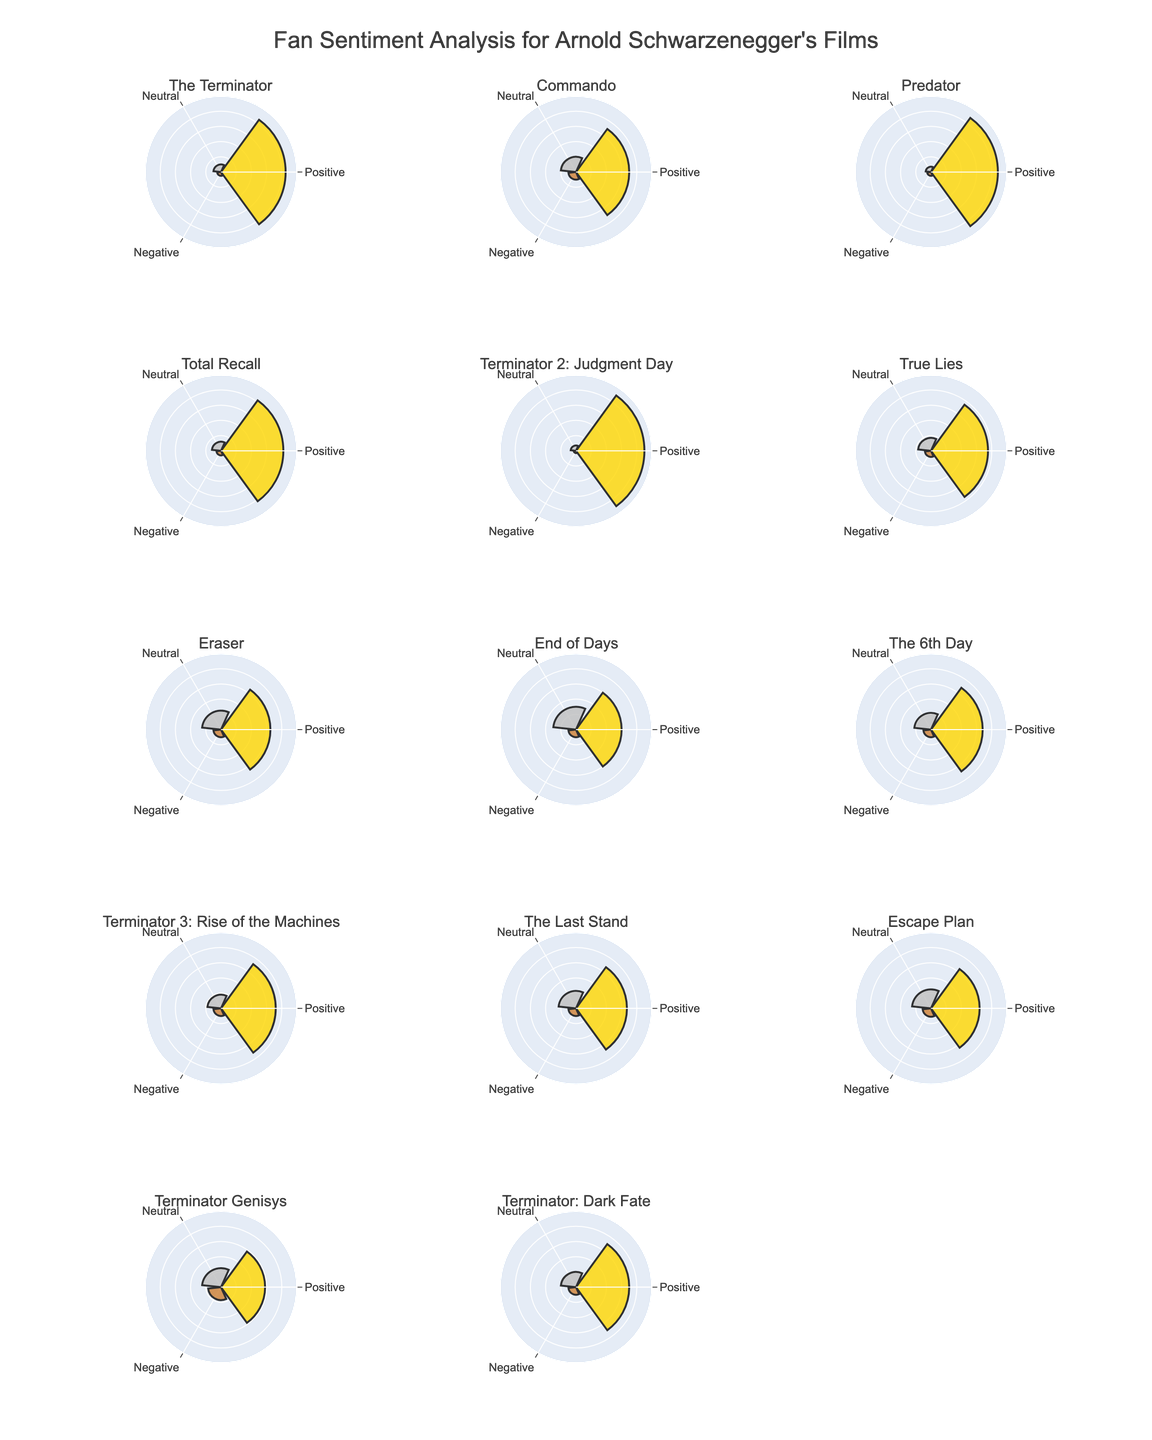Which film has the highest positive sentiment? Look at the proportion of positive sentiment for each film. "Terminator 2: Judgment Day" has the highest positive sentiment at 90%.
Answer: Terminator 2: Judgment Day How does the negative sentiment for "The Terminator" compare to "Predator"? Compare the negative sentiment percentages for both films. "The Terminator" has 5%, while "Predator" also has 5%.
Answer: Equal Which film has the largest percentage of neutral sentiment? Identify the film with the highest neutral sentiment percentage. "End of Days" has the largest at 30%.
Answer: End of Days What is the average positive sentiment percentage across all films? Total the positive percentages for all films and divide by the number of films. Sum: 85+70+88+82+90+75+65+60+68+72+67+64+58+70 = 1014. Number of films: 14. Average: 1014 / 14.
Answer: 72.43 Which film shows the greatest difference between positive and negative sentiment? Calculate the difference between positive and negative sentiment for each film. Find the film with the greatest difference. "Terminator 2: Judgment Day" has a positive-negative difference of 90% - 3% = 87%.
Answer: Terminator 2: Judgment Day Is there any film where the neutral sentiment is greater than the positive sentiment? Compare neutral and positive sentiment for each film. There is no film where the neutral sentiment is greater than the positive sentiment.
Answer: No Which film from the 2000s has the highest positive sentiment? Identify films from the 2000s. Compare their positive sentiments. "Terminator 3: Rise of the Machines" (2003) has the highest positive sentiment among films from the 2000s at 72%.
Answer: Terminator 3: Rise of the Machines What is the total percentage of negative sentiment combined for "Commando" and "Eraser"? Sum the negative sentiments for both films ("Commando": 10%, "Eraser": 10%). Combined: 10 + 10 = 20.
Answer: 20 How does the positive sentiment of "Total Recall" (1990) compare to "The Terminator" (1984)? Compare the positive sentiment percentages for each film. "Total Recall" has 82%, while "The Terminator" has 85%.
Answer: The Terminator has higher positive sentiment than Total Recall Which film has the lowest positive sentiment in the 2010s? Identify the films from the 2010s. Compare their positive sentiments. "Terminator Genisys" (2015) has the lowest positive sentiment at 58%.
Answer: Terminator Genisys 